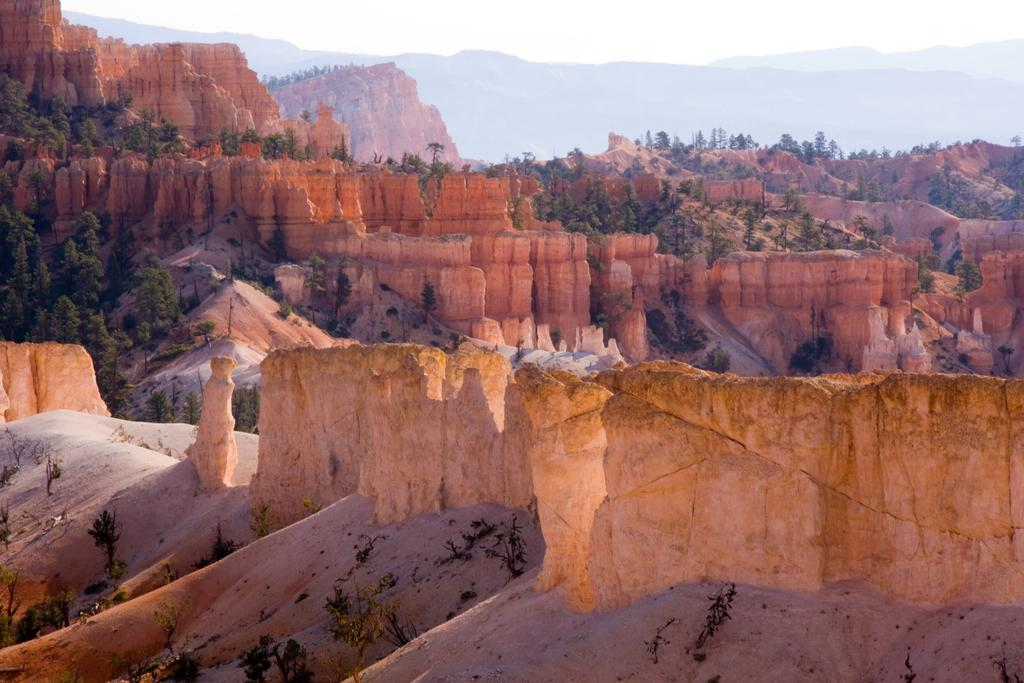What type of natural formation can be seen in the image? There are mountains in the image. What other natural elements are present in the image? There is a group of trees in the image. Can you describe the background of the image? There are more mountains visible in the background. What is visible at the top of the image? The sky is visible at the top of the image. What type of twig is being used as a lamp in the image? There is no twig or lamp present in the image; it features mountains and trees. Can you describe the hand gestures of the trees in the image? There are no hand gestures in the image, as trees do not have hands. 